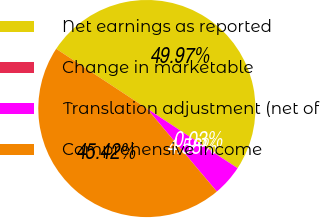<chart> <loc_0><loc_0><loc_500><loc_500><pie_chart><fcel>Net earnings as reported<fcel>Change in marketable<fcel>Translation adjustment (net of<fcel>Comprehensive income<nl><fcel>49.97%<fcel>0.03%<fcel>4.58%<fcel>45.42%<nl></chart> 